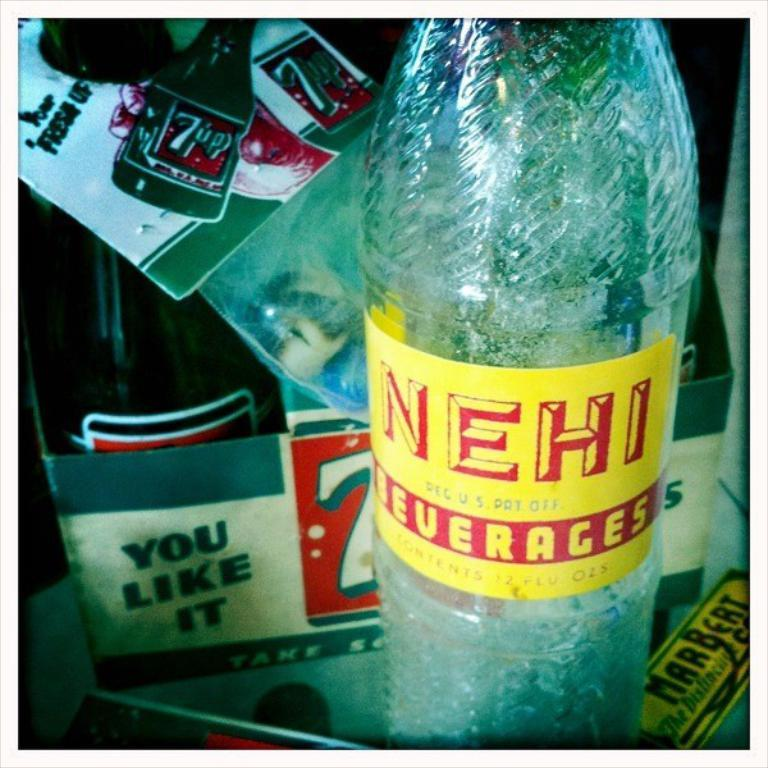What is on the table in the image? There is a bottle with a label on a table. Can you describe anything else in the background of the image? There is another bottle on a box in the background. Does the second bottle have any distinguishing features? Yes, the second bottle also has a label. What is the relation between the two bottles in the image? There is no indication of a relation between the two bottles in the image. They are simply two separate bottles, one on a table and the other on a box in the background. 